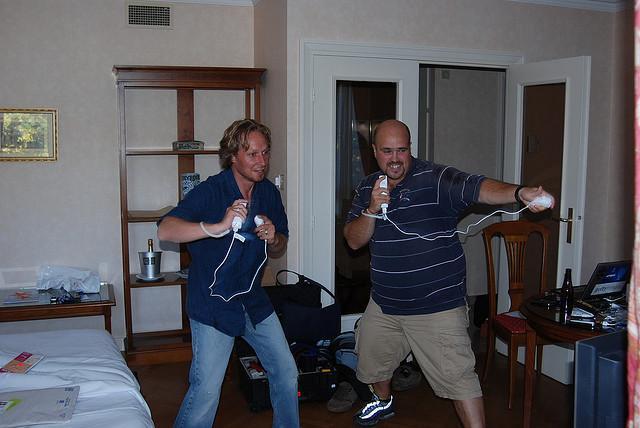How many pictures are on the wall?
Give a very brief answer. 1. How many people are in the picture?
Give a very brief answer. 2. How many people are there?
Give a very brief answer. 2. How many suitcases are visible?
Give a very brief answer. 2. 